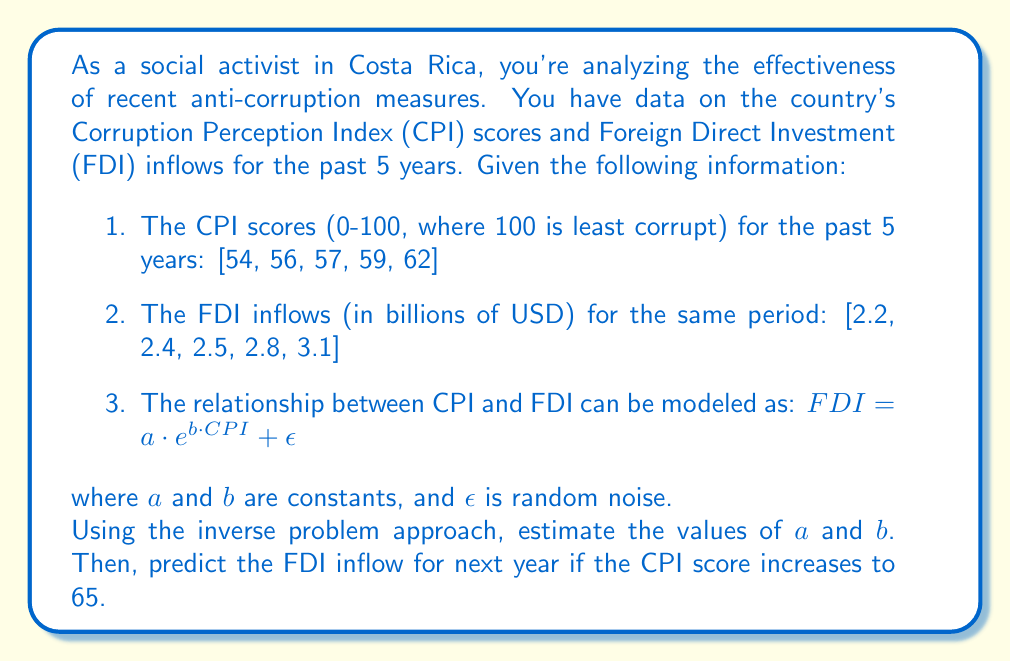What is the answer to this math problem? To solve this inverse problem and estimate the effectiveness of anti-corruption measures, we'll follow these steps:

1. Linearize the model:
   Taking the natural log of both sides (ignoring noise):
   $$\ln(FDI) = \ln(a) + b \cdot CPI$$

   Let $y = \ln(FDI)$ and $x = CPI$. Then our linear model becomes:
   $$y = \ln(a) + bx$$

2. Prepare the data:
   Calculate $y = \ln(FDI)$ for each year:
   $$y = [\ln(2.2), \ln(2.4), \ln(2.5), \ln(2.8), \ln(3.1)]$$
   $$y \approx [0.7885, 0.8755, 0.9163, 1.0296, 1.1314]$$

3. Use linear regression to estimate $\ln(a)$ and $b$:
   We can use the formula:
   $$b = \frac{n\sum xy - \sum x \sum y}{n\sum x^2 - (\sum x)^2}$$
   $$\ln(a) = \bar{y} - b\bar{x}$$

   Calculating the sums:
   $$\sum x = 288, \sum y = 4.7413, \sum xy = 273.9954, \sum x^2 = 16,650$$
   $$n = 5, \bar{x} = 57.6, \bar{y} = 0.9483$$

   Plugging into the formulas:
   $$b = \frac{5(273.9954) - 288(4.7413)}{5(16,650) - 288^2} \approx 0.0431$$
   $$\ln(a) = 0.9483 - 0.0431(57.6) \approx -1.5352$$

4. Convert back to the original model:
   $$a = e^{-1.5352} \approx 0.2155$$

5. Our estimated model is:
   $$FDI = 0.2155 \cdot e^{0.0431 \cdot CPI}$$

6. Predict FDI for CPI = 65:
   $$FDI = 0.2155 \cdot e^{0.0431 \cdot 65} \approx 3.4026$$

Therefore, if the CPI score increases to 65, we predict an FDI inflow of approximately 3.4026 billion USD for next year.
Answer: $a \approx 0.2155$, $b \approx 0.0431$, Predicted FDI ≈ $3.4026$ billion USD 